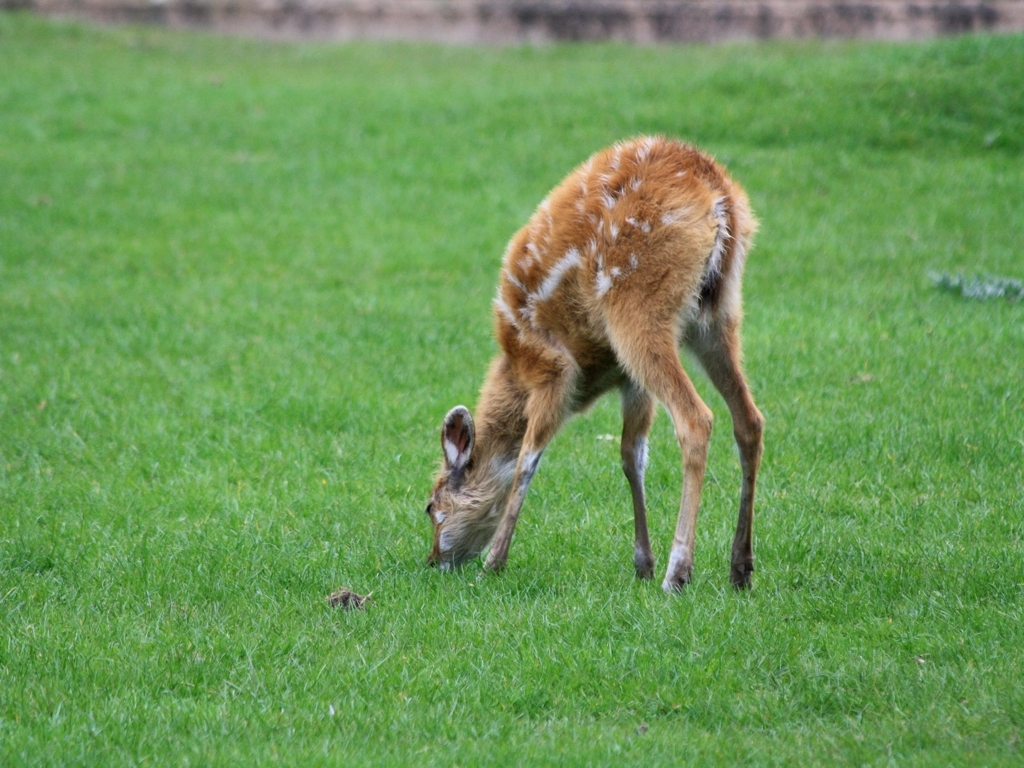Why do fawns have spots on their coat? The spots on a fawn's coat serve as camouflage. They mimic the pattern of sunlight falling through leaves, making the young deer less visible to predators in the dappled light of their forest habitat. 